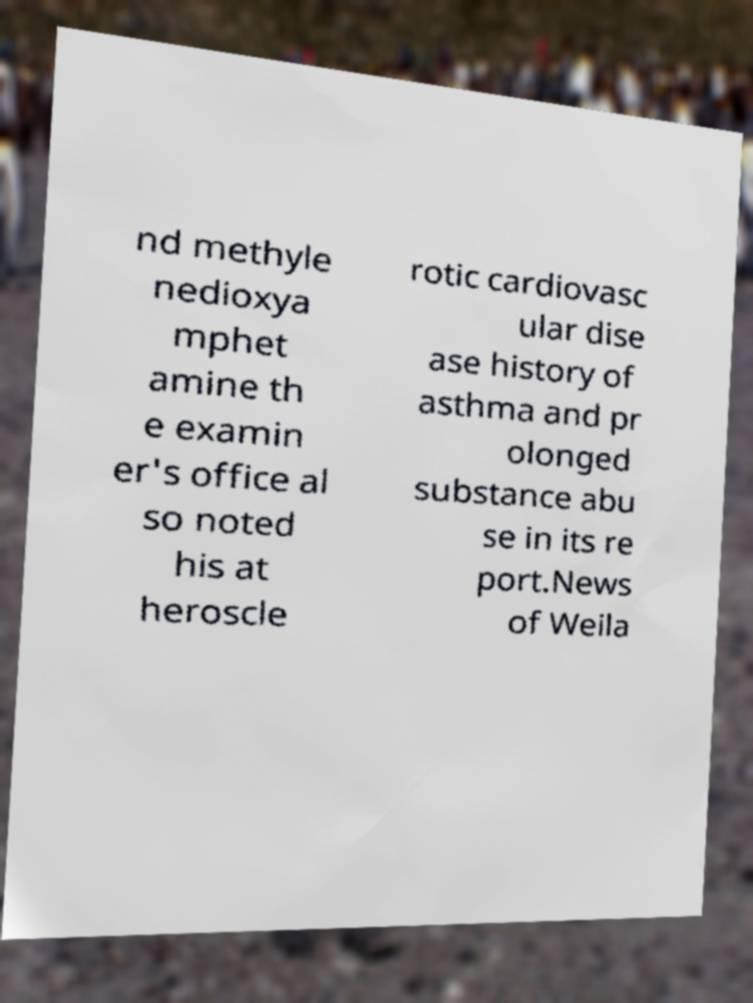What messages or text are displayed in this image? I need them in a readable, typed format. nd methyle nedioxya mphet amine th e examin er's office al so noted his at heroscle rotic cardiovasc ular dise ase history of asthma and pr olonged substance abu se in its re port.News of Weila 